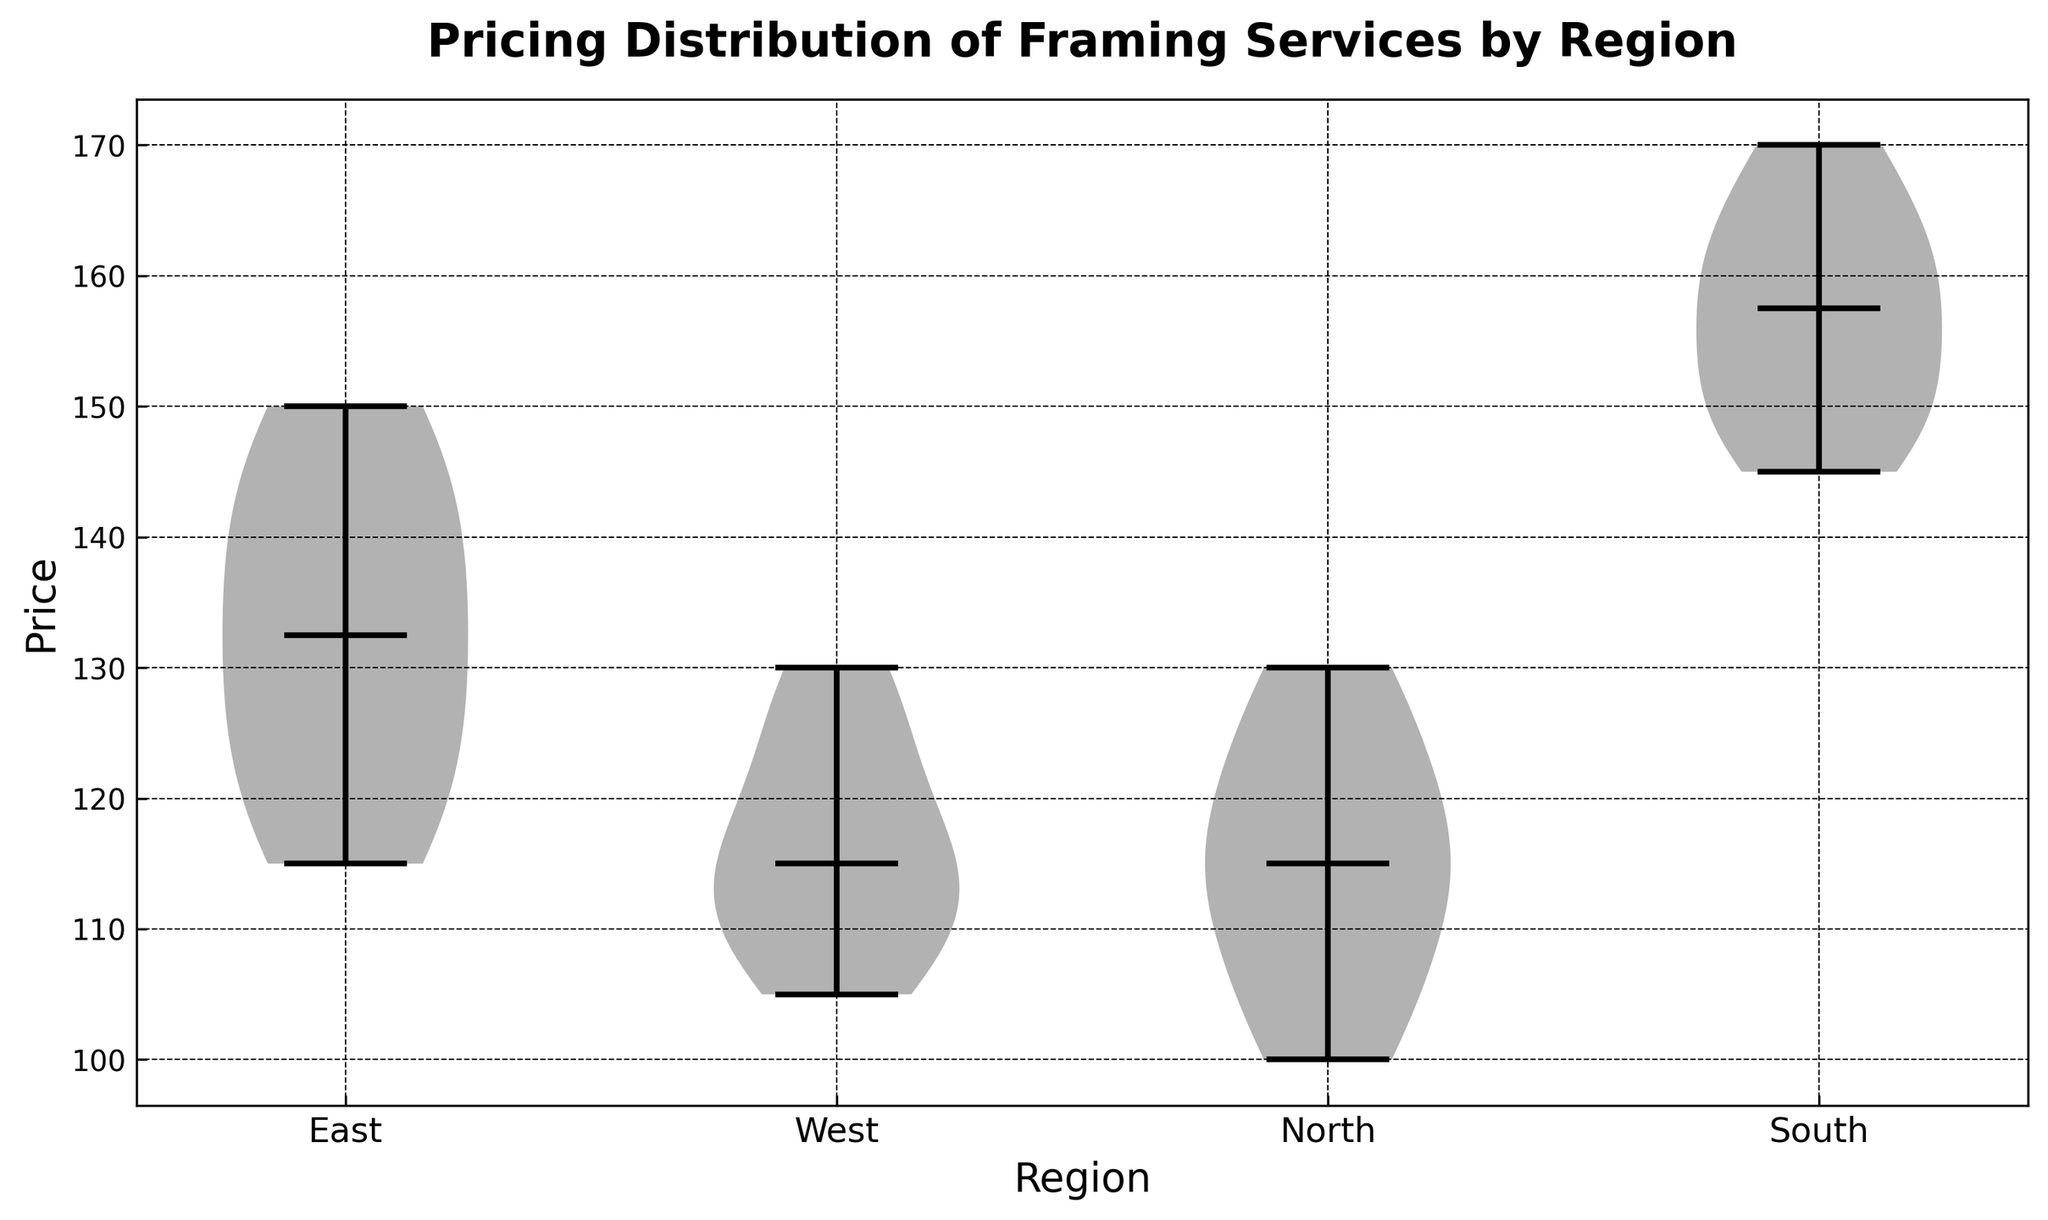What's the median value for prices in the East region? To find the median value of the East region, I would locate the line representing the median within the violin plot for the East region. The line in the middle of the violin shape shows the median price.
Answer: 130 Which region has the largest spread in prices? By observing the length of the violins, I would compare each region’s price distribution. The wider the range, the larger the spread. The South region has visibly the longest violin, indicating the largest spread in prices.
Answer: South Which region has the lowest median price? By comparing the median lines (the horizontal lines) within each violin plot, the North region has the line at the lowest price point.
Answer: North Is the median price for the South region higher than the median price for the East region? I would look at the horizontal median lines within the violin plots for both regions. The South's median line is positioned higher on the y-axis than the East's.
Answer: Yes By how much does the median price in the South region exceed the median price in the North region? Finding the median lines for both South and North regions on the y-axis, the median in South is 160 and in North is 115, the difference is 160 - 115.
Answer: 45 Which region has prices most tightly clustered around the median? The tight clustering of prices can be observed in the tightness of the violin shape around the median line. The West region has a less spread violin shape compared to others.
Answer: West What is the approximate average price in the North region based on the visual distribution? While the average isn't explicitly marked, the clustering of data points around the median can give an estimate. Given the relatively symmetric and narrow spread around 115, the average is likely close to the median.
Answer: Close to 115 Is there a price overlap between the East and West regions? I would compare the ranges of the violins for East and West regions to observe for overlapping y-values. Both regions have prices that overlap between approximately 110 to 140.
Answer: Yes Does the East region show a larger variance in prices compared to the West region? By comparing the spread of the violins, the East region's violin is more spread out than the West region's, indicating a larger variance in prices.
Answer: Yes 